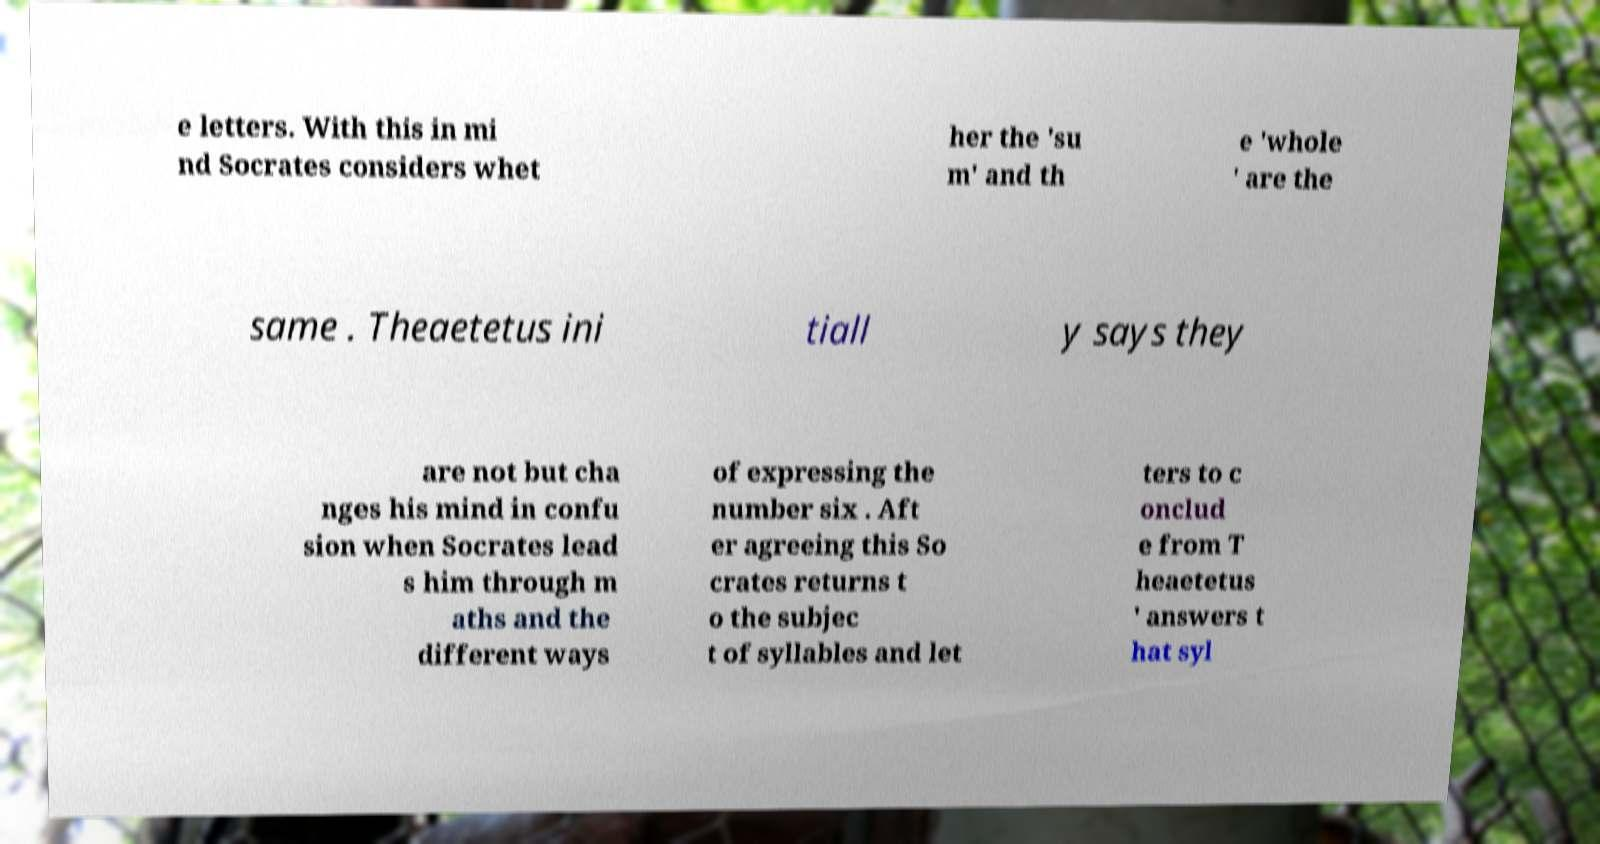Can you read and provide the text displayed in the image?This photo seems to have some interesting text. Can you extract and type it out for me? e letters. With this in mi nd Socrates considers whet her the 'su m' and th e 'whole ' are the same . Theaetetus ini tiall y says they are not but cha nges his mind in confu sion when Socrates lead s him through m aths and the different ways of expressing the number six . Aft er agreeing this So crates returns t o the subjec t of syllables and let ters to c onclud e from T heaetetus ' answers t hat syl 